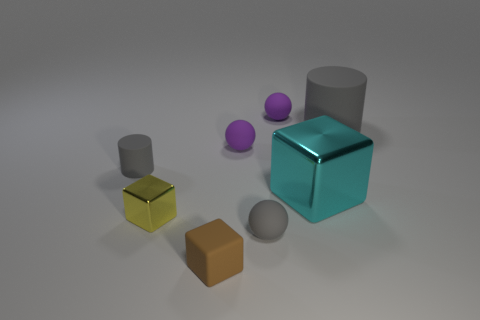The cyan block has what size?
Offer a very short reply. Large. How many big cyan objects have the same shape as the brown thing?
Ensure brevity in your answer.  1. Is the number of big cyan metal objects to the left of the big block the same as the number of small gray cubes?
Provide a succinct answer. Yes. The matte object that is the same size as the cyan block is what shape?
Ensure brevity in your answer.  Cylinder. Is there a tiny green matte thing of the same shape as the yellow metallic thing?
Provide a succinct answer. No. Are there any yellow cubes to the left of the small rubber ball in front of the gray rubber cylinder to the left of the gray rubber ball?
Give a very brief answer. Yes. Are there more matte objects that are in front of the small shiny thing than cyan metallic things on the left side of the big gray cylinder?
Ensure brevity in your answer.  Yes. What material is the yellow block that is the same size as the gray ball?
Keep it short and to the point. Metal. What number of large objects are either rubber blocks or rubber spheres?
Provide a short and direct response. 0. Is the large shiny thing the same shape as the small yellow metallic thing?
Keep it short and to the point. Yes. 